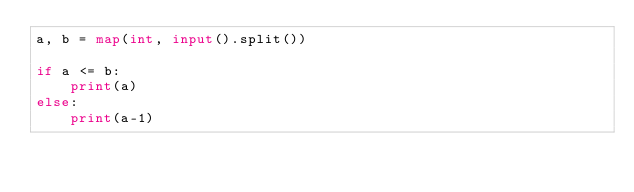<code> <loc_0><loc_0><loc_500><loc_500><_Python_>a, b = map(int, input().split())

if a <= b:
    print(a)
else:
    print(a-1)</code> 